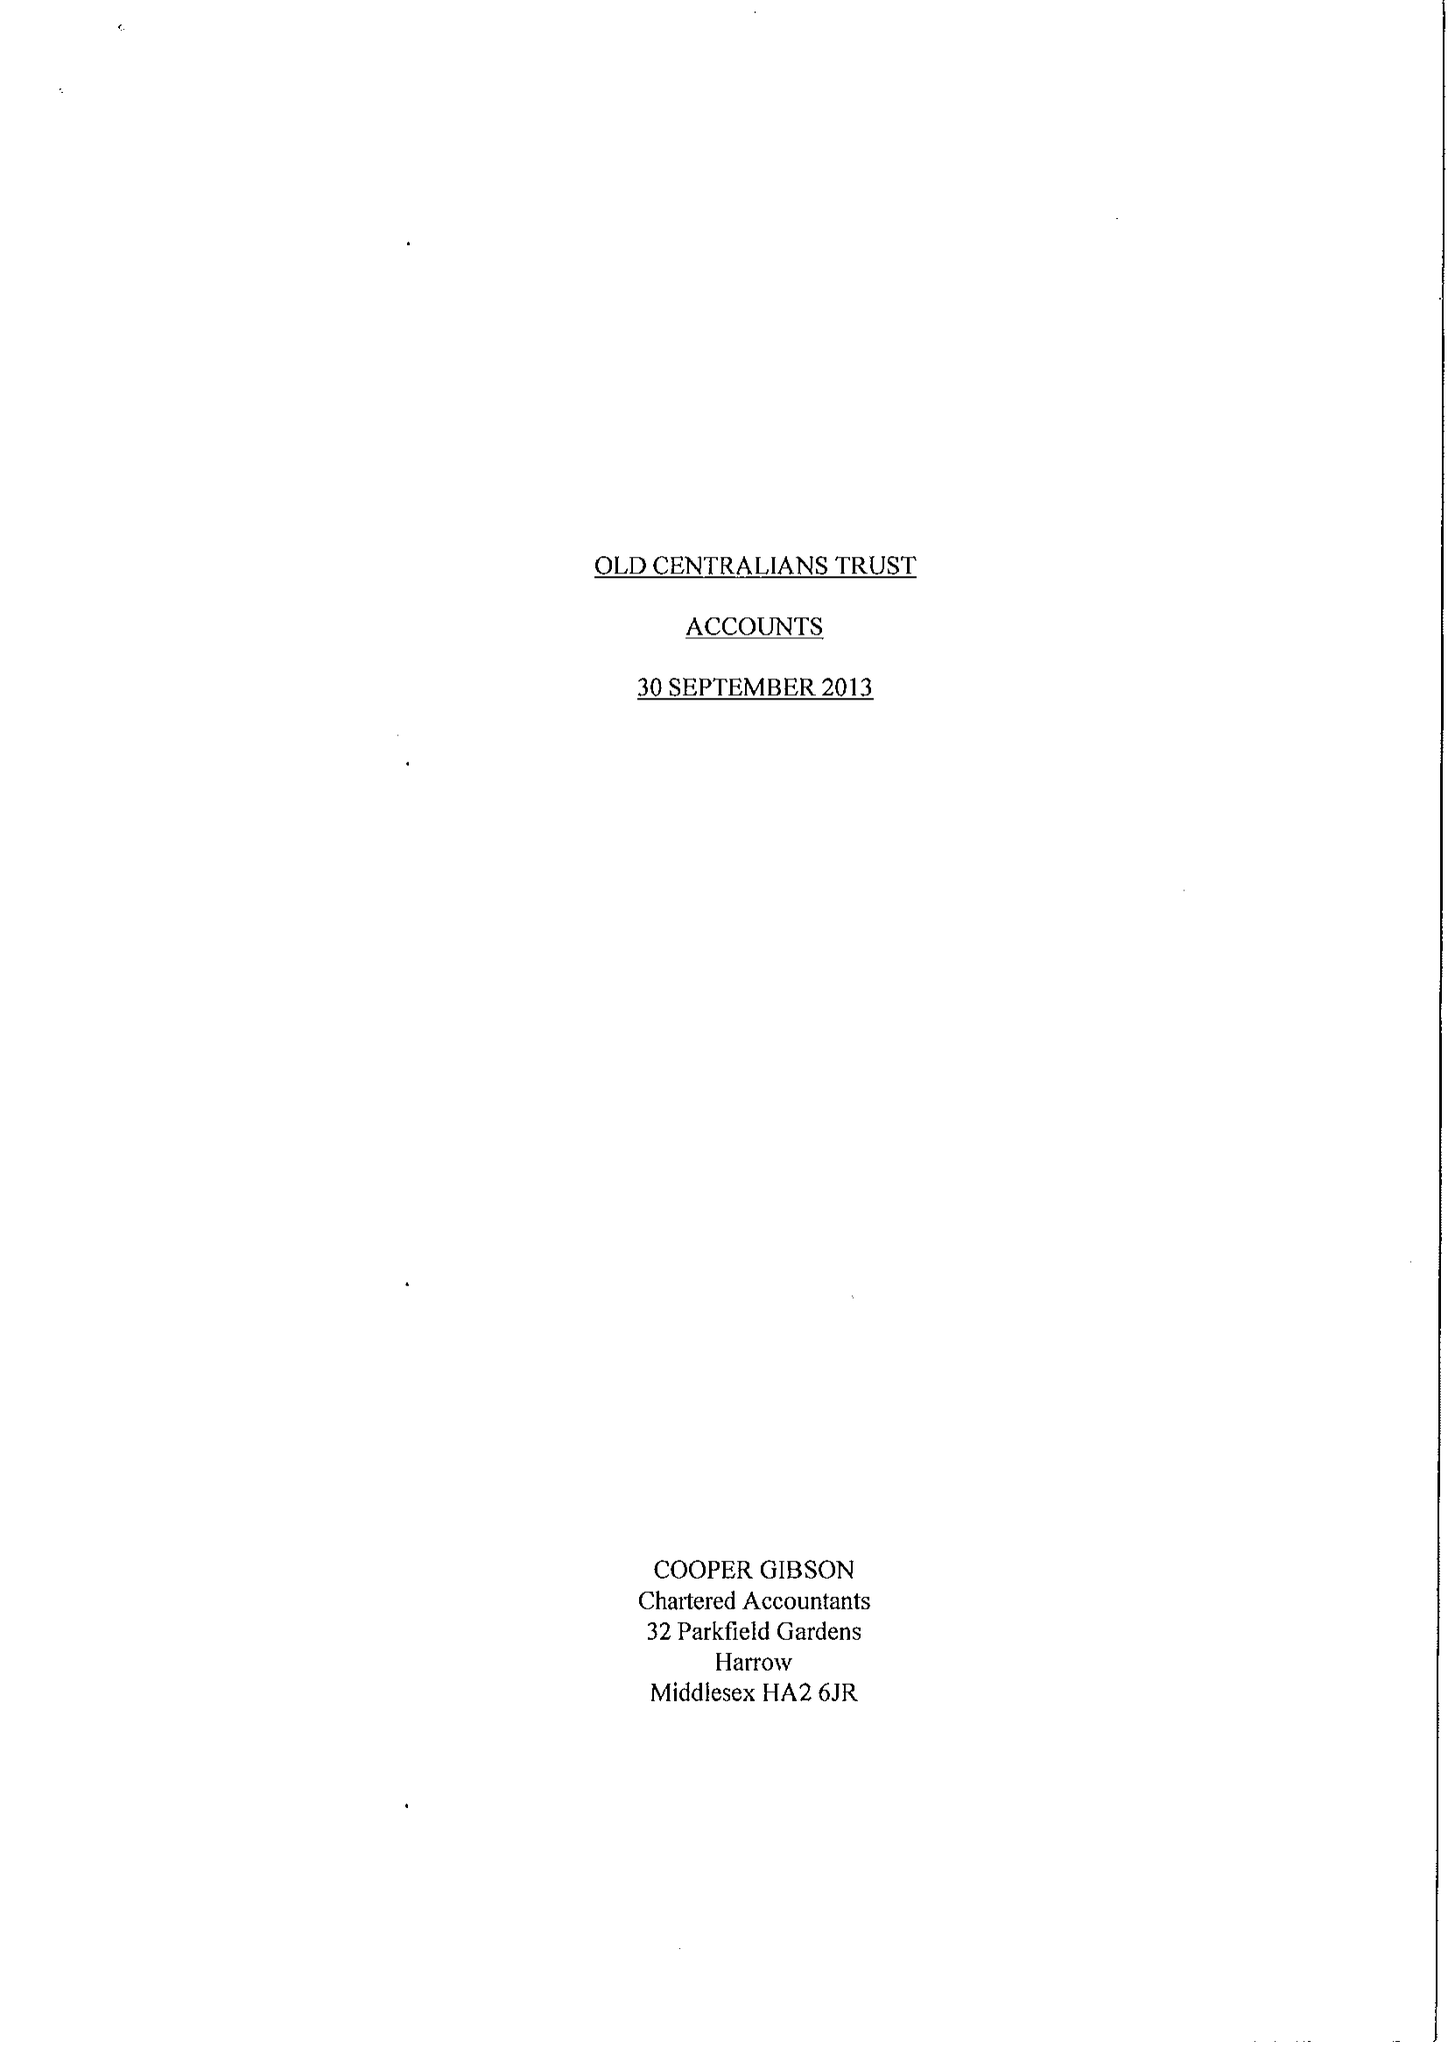What is the value for the address__post_town?
Answer the question using a single word or phrase. LONDON 